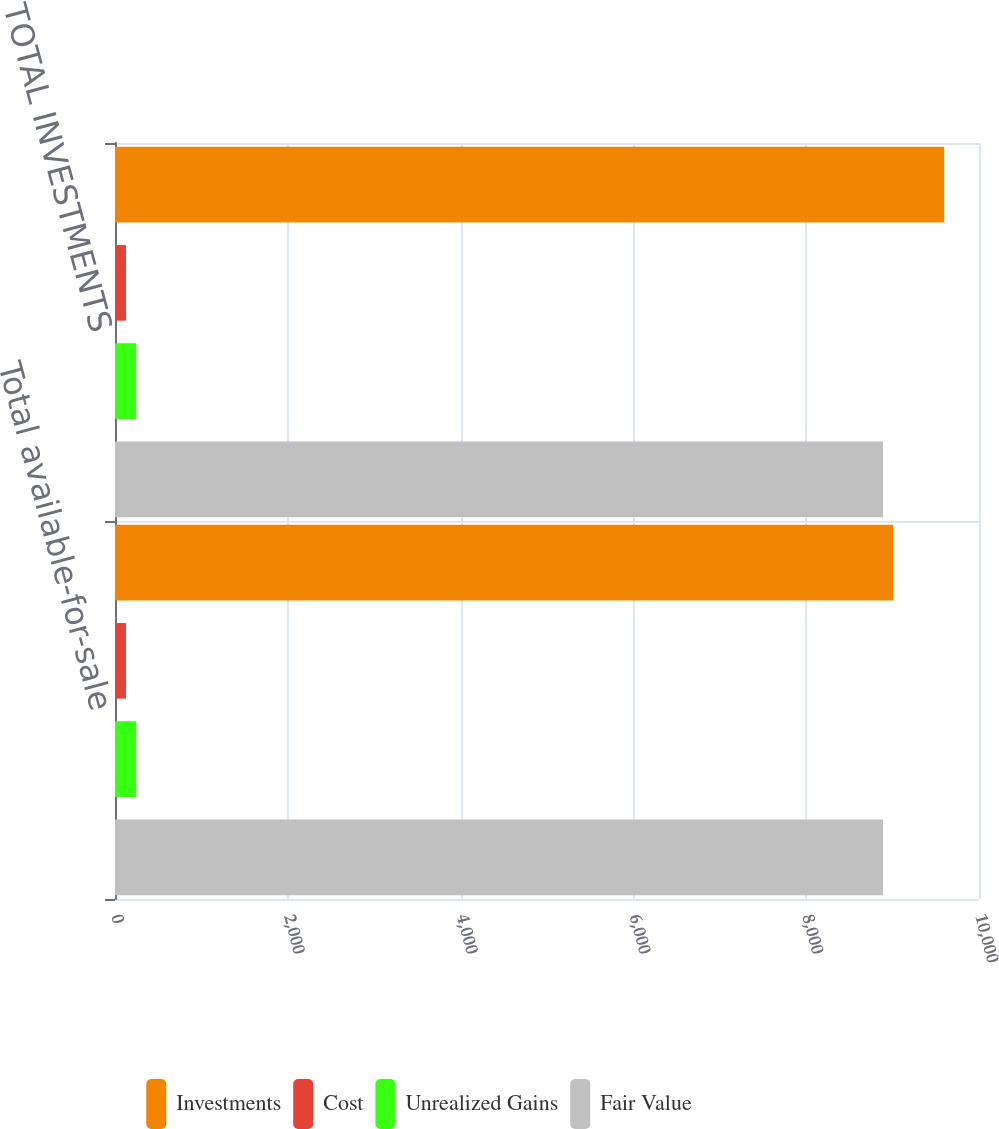Convert chart to OTSL. <chart><loc_0><loc_0><loc_500><loc_500><stacked_bar_chart><ecel><fcel>Total available-for-sale<fcel>TOTAL INVESTMENTS<nl><fcel>Investments<fcel>9008<fcel>9597<nl><fcel>Cost<fcel>127<fcel>127<nl><fcel>Unrealized Gains<fcel>246<fcel>246<nl><fcel>Fair Value<fcel>8889<fcel>8889<nl></chart> 